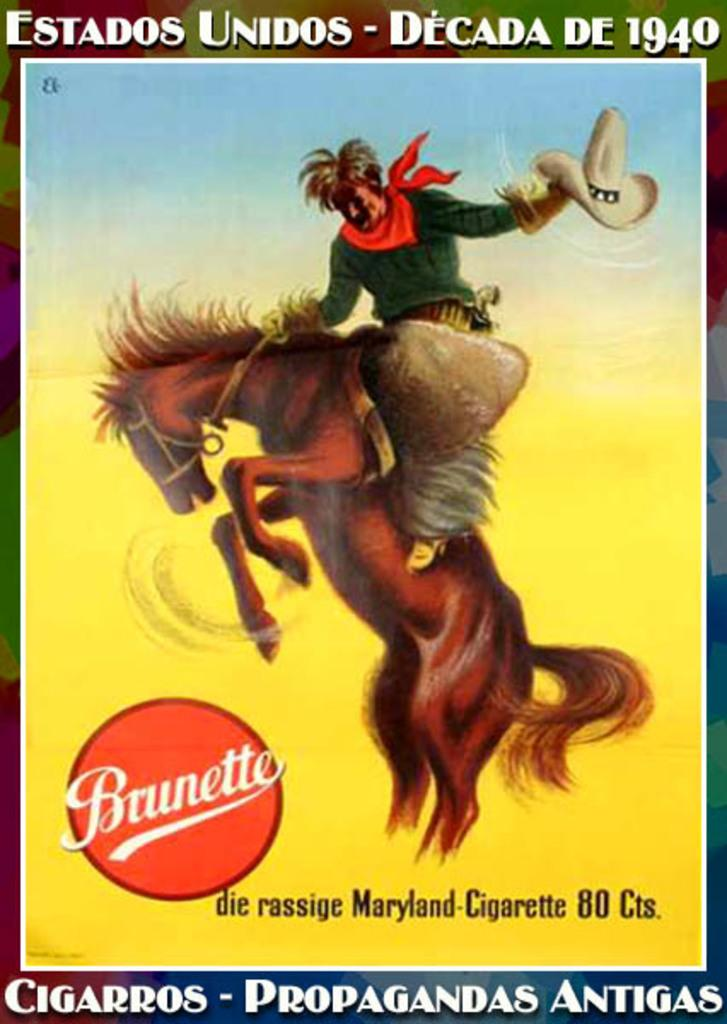What is present in the image? There is a poster in the image. What is shown on the poster? The poster contains an image of a horse and a man. How many balls does the man in the poster own? There is no mention of balls or any indication that the man owns any in the image. 